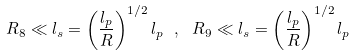Convert formula to latex. <formula><loc_0><loc_0><loc_500><loc_500>R _ { 8 } \ll l _ { s } = \left ( \frac { l _ { p } } { R } \right ) ^ { 1 / 2 } l _ { p } \ , \ R _ { 9 } \ll l _ { s } = \left ( \frac { l _ { p } } { R } \right ) ^ { 1 / 2 } l _ { p }</formula> 